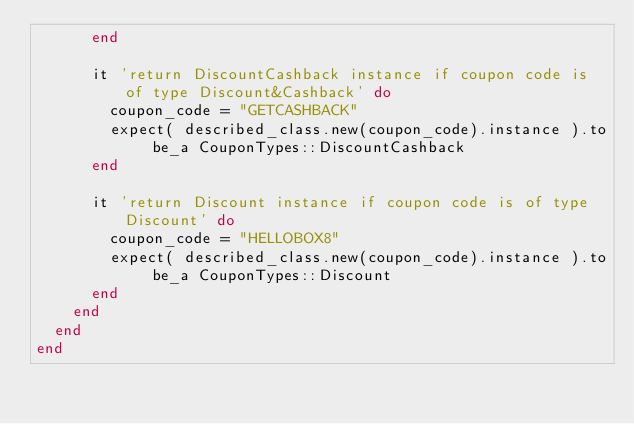Convert code to text. <code><loc_0><loc_0><loc_500><loc_500><_Ruby_>      end

      it 'return DiscountCashback instance if coupon code is of type Discount&Cashback' do
        coupon_code = "GETCASHBACK"
        expect( described_class.new(coupon_code).instance ).to be_a CouponTypes::DiscountCashback
      end

      it 'return Discount instance if coupon code is of type Discount' do
        coupon_code = "HELLOBOX8"
        expect( described_class.new(coupon_code).instance ).to be_a CouponTypes::Discount
      end
    end
  end
end
</code> 